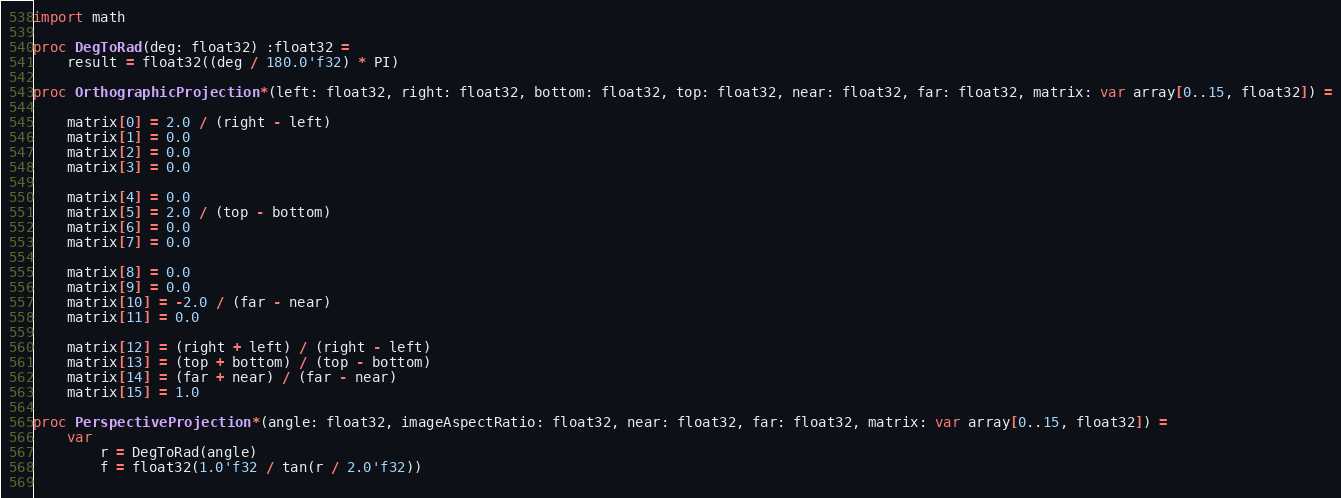Convert code to text. <code><loc_0><loc_0><loc_500><loc_500><_Nim_>import math

proc DegToRad(deg: float32) :float32 =
    result = float32((deg / 180.0'f32) * PI)
        
proc OrthographicProjection*(left: float32, right: float32, bottom: float32, top: float32, near: float32, far: float32, matrix: var array[0..15, float32]) =
       
    matrix[0] = 2.0 / (right - left)
    matrix[1] = 0.0
    matrix[2] = 0.0
    matrix[3] = 0.0
   
    matrix[4] = 0.0
    matrix[5] = 2.0 / (top - bottom)
    matrix[6] = 0.0
    matrix[7] = 0.0
   
    matrix[8] = 0.0
    matrix[9] = 0.0
    matrix[10] = -2.0 / (far - near)
    matrix[11] = 0.0
   
    matrix[12] = (right + left) / (right - left)
    matrix[13] = (top + bottom) / (top - bottom)
    matrix[14] = (far + near) / (far - near)
    matrix[15] = 1.0
    
proc PerspectiveProjection*(angle: float32, imageAspectRatio: float32, near: float32, far: float32, matrix: var array[0..15, float32]) =
    var 
        r = DegToRad(angle)
        f = float32(1.0'f32 / tan(r / 2.0'f32))
        </code> 